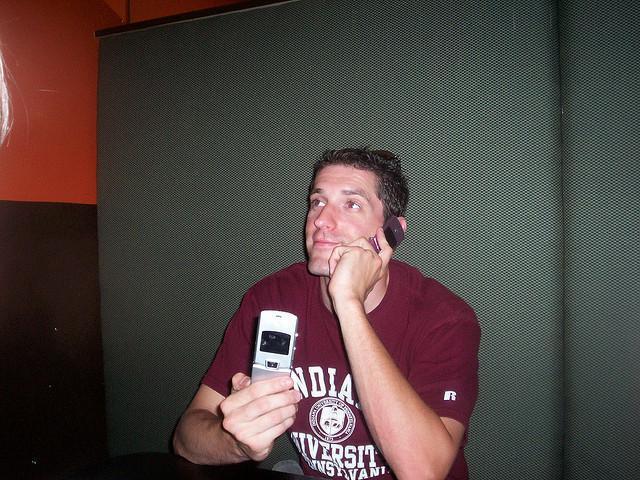How many clocks are in the clock tower?
Give a very brief answer. 0. 